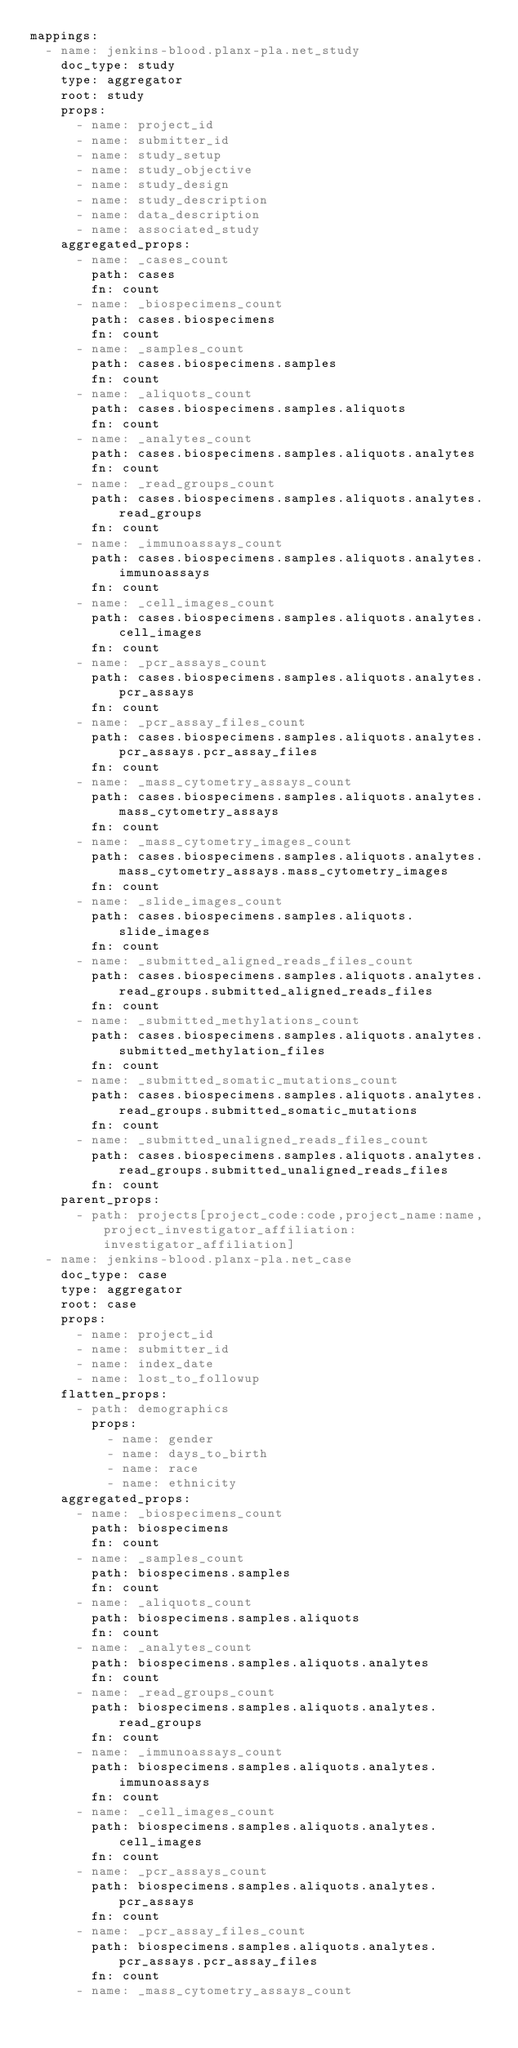Convert code to text. <code><loc_0><loc_0><loc_500><loc_500><_YAML_>mappings:
  - name: jenkins-blood.planx-pla.net_study
    doc_type: study
    type: aggregator
    root: study
    props:
      - name: project_id
      - name: submitter_id
      - name: study_setup
      - name: study_objective
      - name: study_design
      - name: study_description
      - name: data_description
      - name: associated_study
    aggregated_props:
      - name: _cases_count
        path: cases
        fn: count
      - name: _biospecimens_count
        path: cases.biospecimens
        fn: count
      - name: _samples_count
        path: cases.biospecimens.samples
        fn: count
      - name: _aliquots_count
        path: cases.biospecimens.samples.aliquots
        fn: count
      - name: _analytes_count
        path: cases.biospecimens.samples.aliquots.analytes
        fn: count
      - name: _read_groups_count
        path: cases.biospecimens.samples.aliquots.analytes.read_groups
        fn: count
      - name: _immunoassays_count
        path: cases.biospecimens.samples.aliquots.analytes.immunoassays
        fn: count
      - name: _cell_images_count
        path: cases.biospecimens.samples.aliquots.analytes.cell_images
        fn: count
      - name: _pcr_assays_count
        path: cases.biospecimens.samples.aliquots.analytes.pcr_assays
        fn: count
      - name: _pcr_assay_files_count
        path: cases.biospecimens.samples.aliquots.analytes.pcr_assays.pcr_assay_files
        fn: count
      - name: _mass_cytometry_assays_count
        path: cases.biospecimens.samples.aliquots.analytes.mass_cytometry_assays
        fn: count
      - name: _mass_cytometry_images_count
        path: cases.biospecimens.samples.aliquots.analytes.mass_cytometry_assays.mass_cytometry_images
        fn: count
      - name: _slide_images_count
        path: cases.biospecimens.samples.aliquots.slide_images
        fn: count
      - name: _submitted_aligned_reads_files_count
        path: cases.biospecimens.samples.aliquots.analytes.read_groups.submitted_aligned_reads_files
        fn: count
      - name: _submitted_methylations_count
        path: cases.biospecimens.samples.aliquots.analytes.submitted_methylation_files
        fn: count
      - name: _submitted_somatic_mutations_count
        path: cases.biospecimens.samples.aliquots.analytes.read_groups.submitted_somatic_mutations
        fn: count
      - name: _submitted_unaligned_reads_files_count
        path: cases.biospecimens.samples.aliquots.analytes.read_groups.submitted_unaligned_reads_files
        fn: count
    parent_props:
      - path: projects[project_code:code,project_name:name,project_investigator_affiliation:investigator_affiliation]
  - name: jenkins-blood.planx-pla.net_case
    doc_type: case
    type: aggregator
    root: case
    props:
      - name: project_id
      - name: submitter_id
      - name: index_date
      - name: lost_to_followup
    flatten_props:
      - path: demographics
        props:
          - name: gender
          - name: days_to_birth
          - name: race
          - name: ethnicity
    aggregated_props:
      - name: _biospecimens_count
        path: biospecimens
        fn: count
      - name: _samples_count
        path: biospecimens.samples
        fn: count
      - name: _aliquots_count
        path: biospecimens.samples.aliquots
        fn: count
      - name: _analytes_count
        path: biospecimens.samples.aliquots.analytes
        fn: count
      - name: _read_groups_count
        path: biospecimens.samples.aliquots.analytes.read_groups
        fn: count
      - name: _immunoassays_count
        path: biospecimens.samples.aliquots.analytes.immunoassays
        fn: count
      - name: _cell_images_count
        path: biospecimens.samples.aliquots.analytes.cell_images
        fn: count
      - name: _pcr_assays_count
        path: biospecimens.samples.aliquots.analytes.pcr_assays
        fn: count
      - name: _pcr_assay_files_count
        path: biospecimens.samples.aliquots.analytes.pcr_assays.pcr_assay_files
        fn: count
      - name: _mass_cytometry_assays_count</code> 